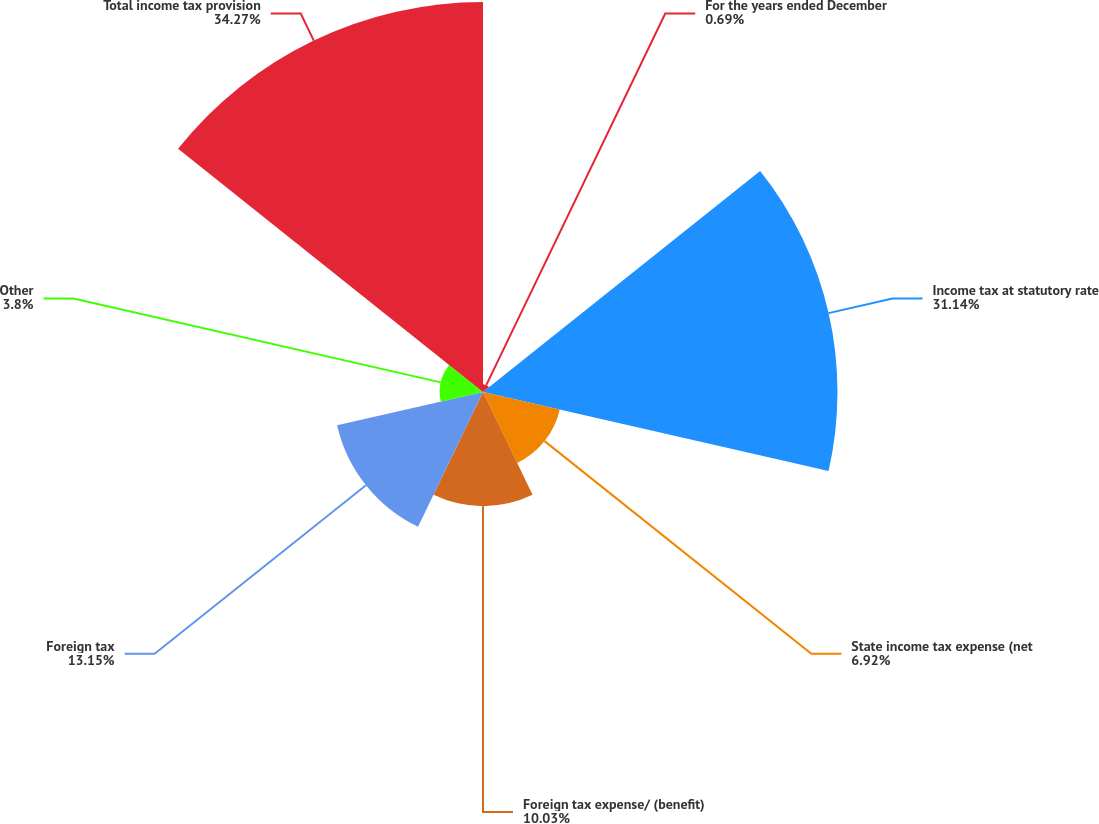<chart> <loc_0><loc_0><loc_500><loc_500><pie_chart><fcel>For the years ended December<fcel>Income tax at statutory rate<fcel>State income tax expense (net<fcel>Foreign tax expense/ (benefit)<fcel>Foreign tax<fcel>Other<fcel>Total income tax provision<nl><fcel>0.69%<fcel>31.14%<fcel>6.92%<fcel>10.03%<fcel>13.15%<fcel>3.8%<fcel>34.26%<nl></chart> 